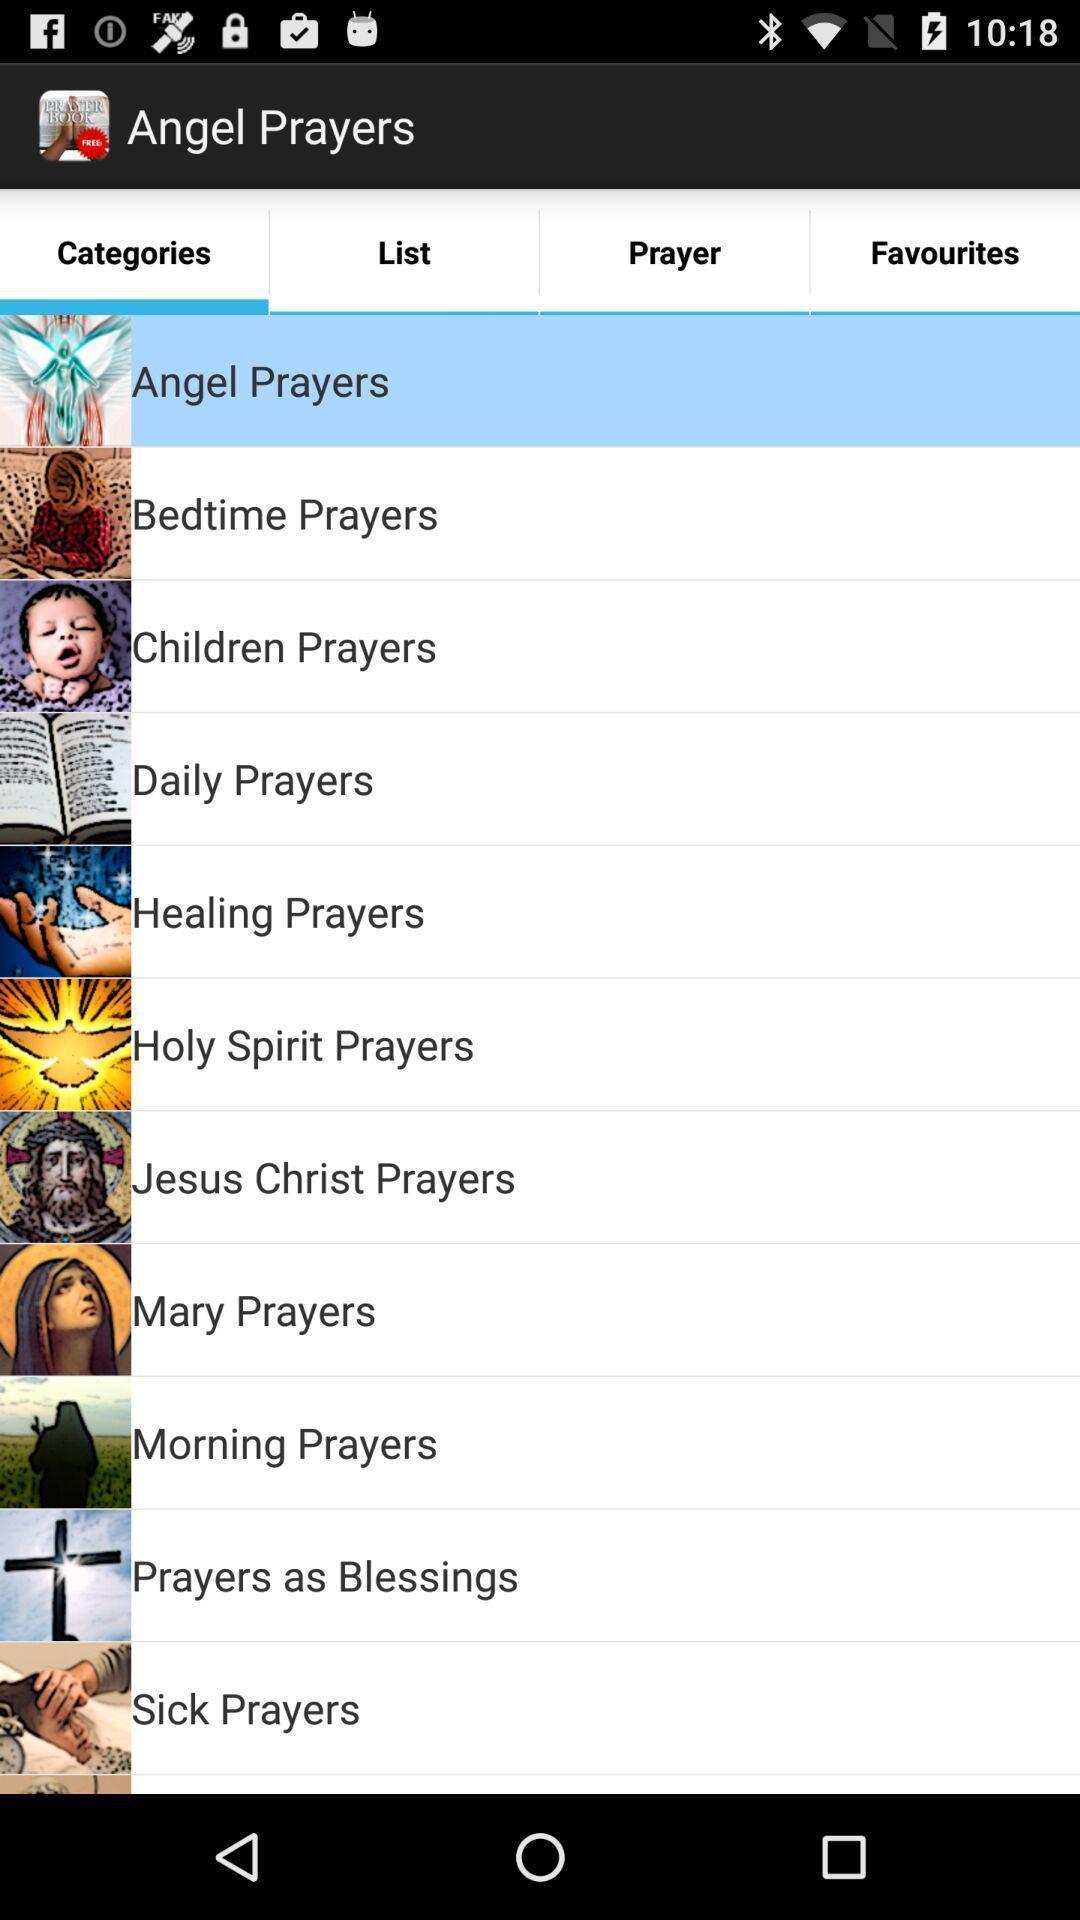Tell me about the visual elements in this screen capture. Page showing about different categories in prayers. 